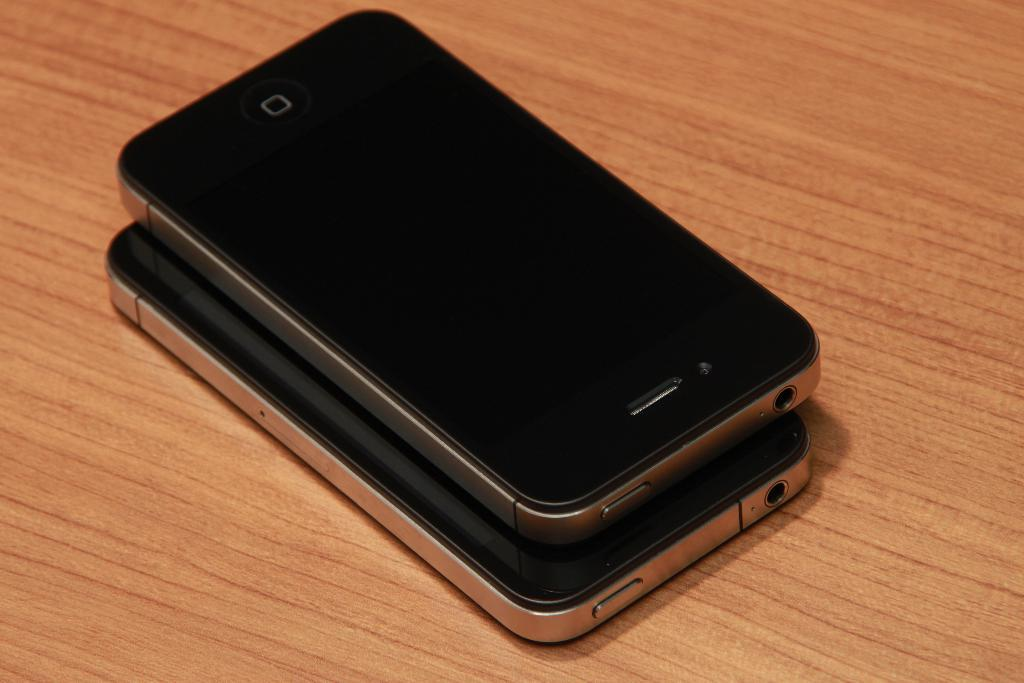What type of surface is visible in the image? There is a wooden surface in the image. What objects are placed on the wooden surface? There are two devices on the wooden surface. How many apples are on the wooden surface in the image? There are no apples present in the image; only two devices are visible on the wooden surface. 